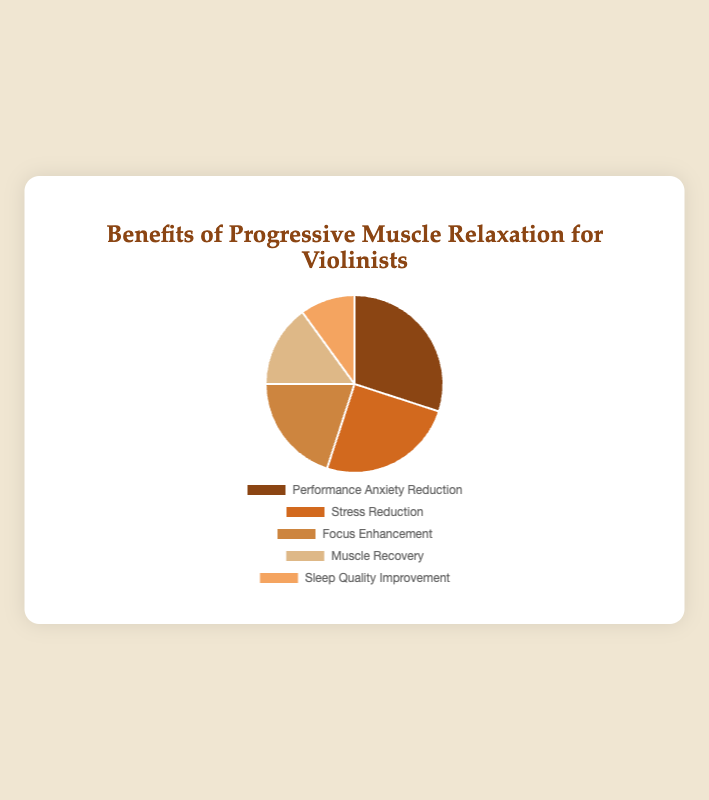Which category represents the largest portion of the benefits? The category with the largest percentage is the one that represents the largest portion. From the data, Performance Anxiety Reduction has the highest percentage of 30%.
Answer: Performance Anxiety Reduction What is the sum of the percentages for Stress Reduction and Sleep Quality Improvement? To find the sum, add the percentages of Stress Reduction and Sleep Quality Improvement. Stress Reduction is 25%, and Sleep Quality Improvement is 10%. So, 25% + 10% = 35%.
Answer: 35% Which benefit category covers the smallest portion of the pie chart? The category with the smallest percentage represents the smallest portion of the pie chart. From the data, Sleep Quality Improvement has the smallest percentage of 10%.
Answer: Sleep Quality Improvement Is the percentage for Performance Anxiety Reduction greater than the percentage for Muscle Recovery and Sleep Quality Improvement combined? Add the percentages of Muscle Recovery and Sleep Quality Improvement: 15% (Muscle Recovery) + 10% (Sleep Quality Improvement) = 25%. Since Performance Anxiety Reduction is 30%, 30% > 25%.
Answer: Yes How does the percentage of Focus Enhancement compare to that of Muscle Recovery? The percentage of Focus Enhancement is 20%, while Muscle Recovery is 15%. Comparing these, 20% is greater than 15%.
Answer: Focus Enhancement is greater What is the difference between the percentages of Performance Anxiety Reduction and Focus Enhancement? Subtract the percentage of Focus Enhancement from that of Performance Anxiety Reduction: 30% - 20% = 10%.
Answer: 10% What two categories combined account for half of the pie chart? To find two categories that add up to 50%, we need to look for any pair whose percentages sum to 50%. Stress Reduction (25%) and Performance Anxiety Reduction (30%) combined are 55%, which is not exact, so let's consider other possibilities. Muscle Recovery (15%) and Performance Anxiety Reduction (30%) combined are 45%. The pair Focus Enhancement (20%) and Performance Anxiety Reduction (30%) combined are 50%.
Answer: Focus Enhancement and Performance Anxiety Reduction What is the average percentage of all categories? To find the average percentage, sum all percentages and divide by the number of categories. Sum is 25% (Stress Reduction) + 20% (Focus Enhancement) + 30% (Performance Anxiety Reduction) + 15% (Muscle Recovery) + 10% (Sleep Quality Improvement) = 100%. There are 5 categories, so 100% / 5 = 20%.
Answer: 20% Which category, denoted by the second darkest shade of brown, represents what percentage? In most graphical visualizations, colors usually go from darkest to lightest. Assuming the darkest brown represents Performance Anxiety Reduction (30%) and the second darkest brown represents Stress Reduction, the second darkest would be Stress Reduction.
Answer: Stress Reduction represents 25% If the percentage of Stress Reduction doubled, what would be its new value and how would it rank among the categories? If the percentage of Stress Reduction (currently 25%) doubled, it would be 25% * 2 = 50%. This would make it the highest percentage, surpassing Performance Anxiety Reduction (30%), making it rank first.
Answer: New value is 50%, and it would rank 1st 